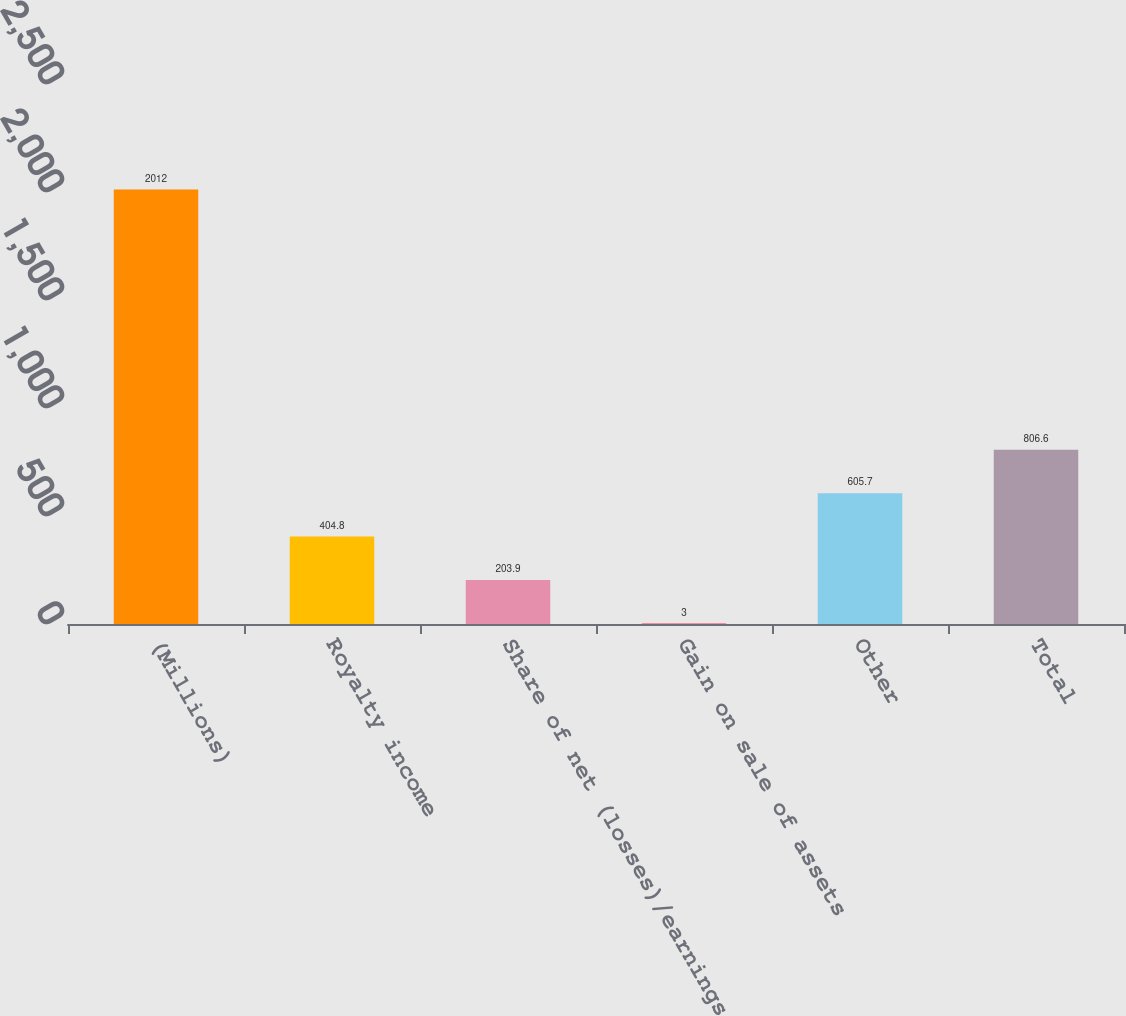<chart> <loc_0><loc_0><loc_500><loc_500><bar_chart><fcel>(Millions)<fcel>Royalty income<fcel>Share of net (losses)/earnings<fcel>Gain on sale of assets<fcel>Other<fcel>Total<nl><fcel>2012<fcel>404.8<fcel>203.9<fcel>3<fcel>605.7<fcel>806.6<nl></chart> 